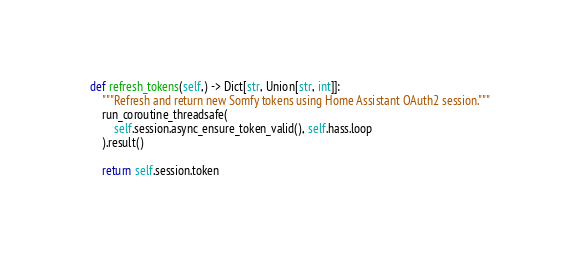<code> <loc_0><loc_0><loc_500><loc_500><_Python_>
    def refresh_tokens(self,) -> Dict[str, Union[str, int]]:
        """Refresh and return new Somfy tokens using Home Assistant OAuth2 session."""
        run_coroutine_threadsafe(
            self.session.async_ensure_token_valid(), self.hass.loop
        ).result()

        return self.session.token
</code> 